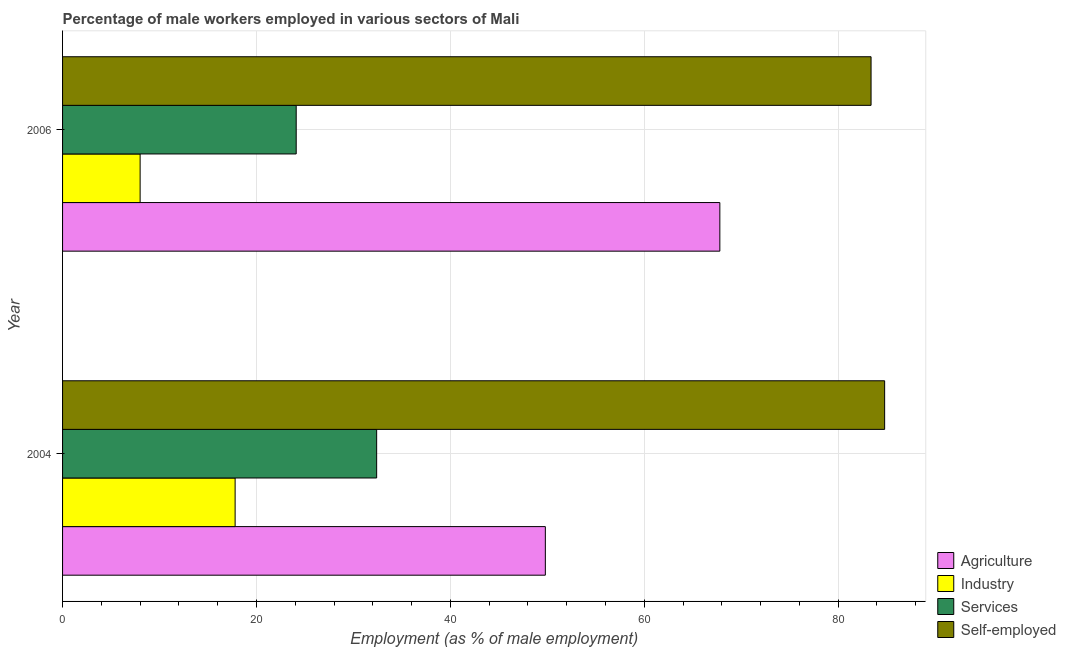How many different coloured bars are there?
Give a very brief answer. 4. How many groups of bars are there?
Provide a succinct answer. 2. Are the number of bars per tick equal to the number of legend labels?
Your answer should be very brief. Yes. How many bars are there on the 1st tick from the bottom?
Make the answer very short. 4. In how many cases, is the number of bars for a given year not equal to the number of legend labels?
Make the answer very short. 0. What is the percentage of self employed male workers in 2004?
Your answer should be very brief. 84.8. Across all years, what is the maximum percentage of male workers in agriculture?
Offer a terse response. 67.8. Across all years, what is the minimum percentage of male workers in agriculture?
Your answer should be compact. 49.8. In which year was the percentage of male workers in industry maximum?
Your response must be concise. 2004. In which year was the percentage of male workers in agriculture minimum?
Offer a very short reply. 2004. What is the total percentage of male workers in agriculture in the graph?
Your answer should be compact. 117.6. What is the difference between the percentage of male workers in agriculture in 2004 and the percentage of self employed male workers in 2006?
Your answer should be compact. -33.6. What is the average percentage of self employed male workers per year?
Make the answer very short. 84.1. In how many years, is the percentage of male workers in services greater than 40 %?
Give a very brief answer. 0. What is the ratio of the percentage of male workers in industry in 2004 to that in 2006?
Your response must be concise. 2.23. Is the percentage of male workers in services in 2004 less than that in 2006?
Your answer should be very brief. No. Is the difference between the percentage of self employed male workers in 2004 and 2006 greater than the difference between the percentage of male workers in services in 2004 and 2006?
Offer a very short reply. No. In how many years, is the percentage of male workers in services greater than the average percentage of male workers in services taken over all years?
Offer a terse response. 1. What does the 1st bar from the top in 2006 represents?
Keep it short and to the point. Self-employed. What does the 4th bar from the bottom in 2004 represents?
Keep it short and to the point. Self-employed. Are all the bars in the graph horizontal?
Keep it short and to the point. Yes. What is the difference between two consecutive major ticks on the X-axis?
Your response must be concise. 20. Does the graph contain any zero values?
Your answer should be compact. No. Does the graph contain grids?
Ensure brevity in your answer.  Yes. How are the legend labels stacked?
Give a very brief answer. Vertical. What is the title of the graph?
Ensure brevity in your answer.  Percentage of male workers employed in various sectors of Mali. What is the label or title of the X-axis?
Your answer should be very brief. Employment (as % of male employment). What is the label or title of the Y-axis?
Provide a short and direct response. Year. What is the Employment (as % of male employment) of Agriculture in 2004?
Provide a short and direct response. 49.8. What is the Employment (as % of male employment) of Industry in 2004?
Offer a very short reply. 17.8. What is the Employment (as % of male employment) of Services in 2004?
Your answer should be very brief. 32.4. What is the Employment (as % of male employment) of Self-employed in 2004?
Your answer should be compact. 84.8. What is the Employment (as % of male employment) of Agriculture in 2006?
Your answer should be very brief. 67.8. What is the Employment (as % of male employment) of Industry in 2006?
Keep it short and to the point. 8. What is the Employment (as % of male employment) in Services in 2006?
Provide a succinct answer. 24.1. What is the Employment (as % of male employment) in Self-employed in 2006?
Offer a very short reply. 83.4. Across all years, what is the maximum Employment (as % of male employment) of Agriculture?
Provide a short and direct response. 67.8. Across all years, what is the maximum Employment (as % of male employment) of Industry?
Your answer should be compact. 17.8. Across all years, what is the maximum Employment (as % of male employment) of Services?
Make the answer very short. 32.4. Across all years, what is the maximum Employment (as % of male employment) in Self-employed?
Ensure brevity in your answer.  84.8. Across all years, what is the minimum Employment (as % of male employment) of Agriculture?
Give a very brief answer. 49.8. Across all years, what is the minimum Employment (as % of male employment) of Services?
Make the answer very short. 24.1. Across all years, what is the minimum Employment (as % of male employment) in Self-employed?
Make the answer very short. 83.4. What is the total Employment (as % of male employment) in Agriculture in the graph?
Ensure brevity in your answer.  117.6. What is the total Employment (as % of male employment) of Industry in the graph?
Offer a terse response. 25.8. What is the total Employment (as % of male employment) in Services in the graph?
Keep it short and to the point. 56.5. What is the total Employment (as % of male employment) in Self-employed in the graph?
Your answer should be very brief. 168.2. What is the difference between the Employment (as % of male employment) in Agriculture in 2004 and the Employment (as % of male employment) in Industry in 2006?
Your answer should be compact. 41.8. What is the difference between the Employment (as % of male employment) of Agriculture in 2004 and the Employment (as % of male employment) of Services in 2006?
Your answer should be very brief. 25.7. What is the difference between the Employment (as % of male employment) of Agriculture in 2004 and the Employment (as % of male employment) of Self-employed in 2006?
Your answer should be very brief. -33.6. What is the difference between the Employment (as % of male employment) of Industry in 2004 and the Employment (as % of male employment) of Services in 2006?
Your answer should be very brief. -6.3. What is the difference between the Employment (as % of male employment) in Industry in 2004 and the Employment (as % of male employment) in Self-employed in 2006?
Ensure brevity in your answer.  -65.6. What is the difference between the Employment (as % of male employment) of Services in 2004 and the Employment (as % of male employment) of Self-employed in 2006?
Keep it short and to the point. -51. What is the average Employment (as % of male employment) in Agriculture per year?
Your answer should be very brief. 58.8. What is the average Employment (as % of male employment) in Services per year?
Provide a succinct answer. 28.25. What is the average Employment (as % of male employment) in Self-employed per year?
Your answer should be very brief. 84.1. In the year 2004, what is the difference between the Employment (as % of male employment) in Agriculture and Employment (as % of male employment) in Self-employed?
Offer a terse response. -35. In the year 2004, what is the difference between the Employment (as % of male employment) of Industry and Employment (as % of male employment) of Services?
Give a very brief answer. -14.6. In the year 2004, what is the difference between the Employment (as % of male employment) of Industry and Employment (as % of male employment) of Self-employed?
Your answer should be very brief. -67. In the year 2004, what is the difference between the Employment (as % of male employment) in Services and Employment (as % of male employment) in Self-employed?
Your answer should be very brief. -52.4. In the year 2006, what is the difference between the Employment (as % of male employment) of Agriculture and Employment (as % of male employment) of Industry?
Provide a short and direct response. 59.8. In the year 2006, what is the difference between the Employment (as % of male employment) of Agriculture and Employment (as % of male employment) of Services?
Give a very brief answer. 43.7. In the year 2006, what is the difference between the Employment (as % of male employment) in Agriculture and Employment (as % of male employment) in Self-employed?
Offer a terse response. -15.6. In the year 2006, what is the difference between the Employment (as % of male employment) of Industry and Employment (as % of male employment) of Services?
Make the answer very short. -16.1. In the year 2006, what is the difference between the Employment (as % of male employment) of Industry and Employment (as % of male employment) of Self-employed?
Ensure brevity in your answer.  -75.4. In the year 2006, what is the difference between the Employment (as % of male employment) of Services and Employment (as % of male employment) of Self-employed?
Your answer should be compact. -59.3. What is the ratio of the Employment (as % of male employment) in Agriculture in 2004 to that in 2006?
Provide a short and direct response. 0.73. What is the ratio of the Employment (as % of male employment) of Industry in 2004 to that in 2006?
Your answer should be very brief. 2.23. What is the ratio of the Employment (as % of male employment) in Services in 2004 to that in 2006?
Give a very brief answer. 1.34. What is the ratio of the Employment (as % of male employment) in Self-employed in 2004 to that in 2006?
Keep it short and to the point. 1.02. What is the difference between the highest and the second highest Employment (as % of male employment) of Services?
Your answer should be compact. 8.3. What is the difference between the highest and the second highest Employment (as % of male employment) of Self-employed?
Offer a very short reply. 1.4. What is the difference between the highest and the lowest Employment (as % of male employment) of Services?
Give a very brief answer. 8.3. What is the difference between the highest and the lowest Employment (as % of male employment) of Self-employed?
Make the answer very short. 1.4. 